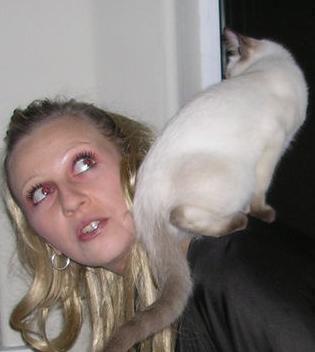How many people are there?
Give a very brief answer. 1. How many zebras are in this picture?
Give a very brief answer. 0. 